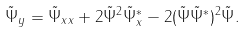<formula> <loc_0><loc_0><loc_500><loc_500>\tilde { \Psi } _ { y } = \tilde { \Psi } _ { x x } + 2 \tilde { \Psi } ^ { 2 } \tilde { \Psi } _ { x } ^ { * } - 2 ( \tilde { \Psi } \tilde { \Psi } ^ { * } ) ^ { 2 } \tilde { \Psi } .</formula> 